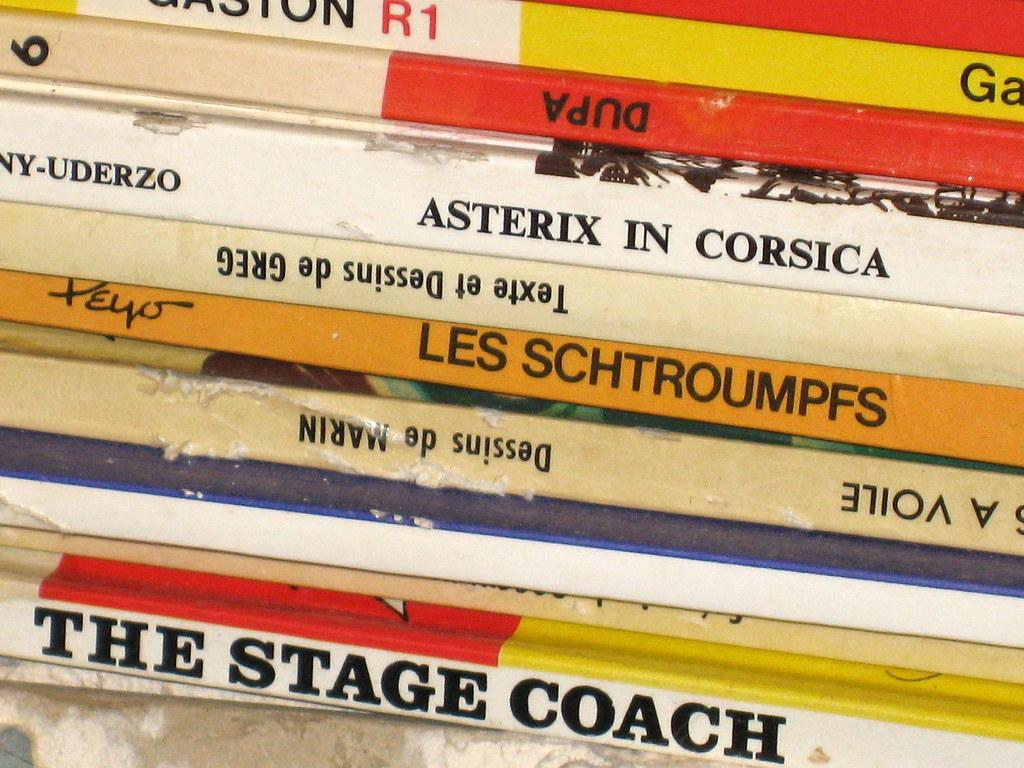Provide a one-sentence caption for the provided image. Many books stacked and one of them is titled the stage coach. 